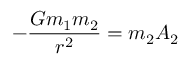Convert formula to latex. <formula><loc_0><loc_0><loc_500><loc_500>- { \frac { G m _ { 1 } m _ { 2 } } { r ^ { 2 } } } = m _ { 2 } A _ { 2 }</formula> 